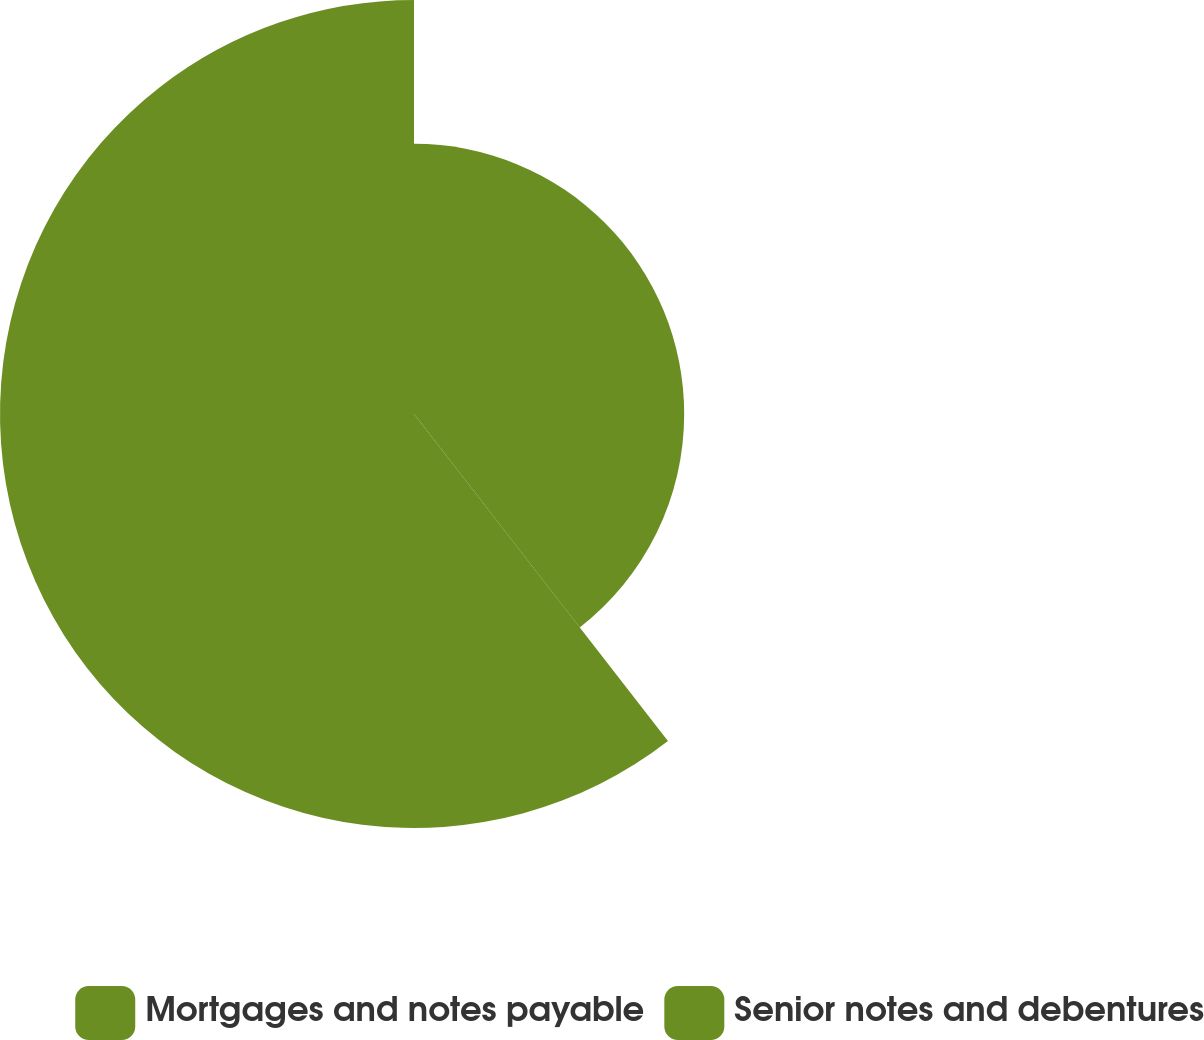<chart> <loc_0><loc_0><loc_500><loc_500><pie_chart><fcel>Mortgages and notes payable<fcel>Senior notes and debentures<nl><fcel>39.49%<fcel>60.51%<nl></chart> 